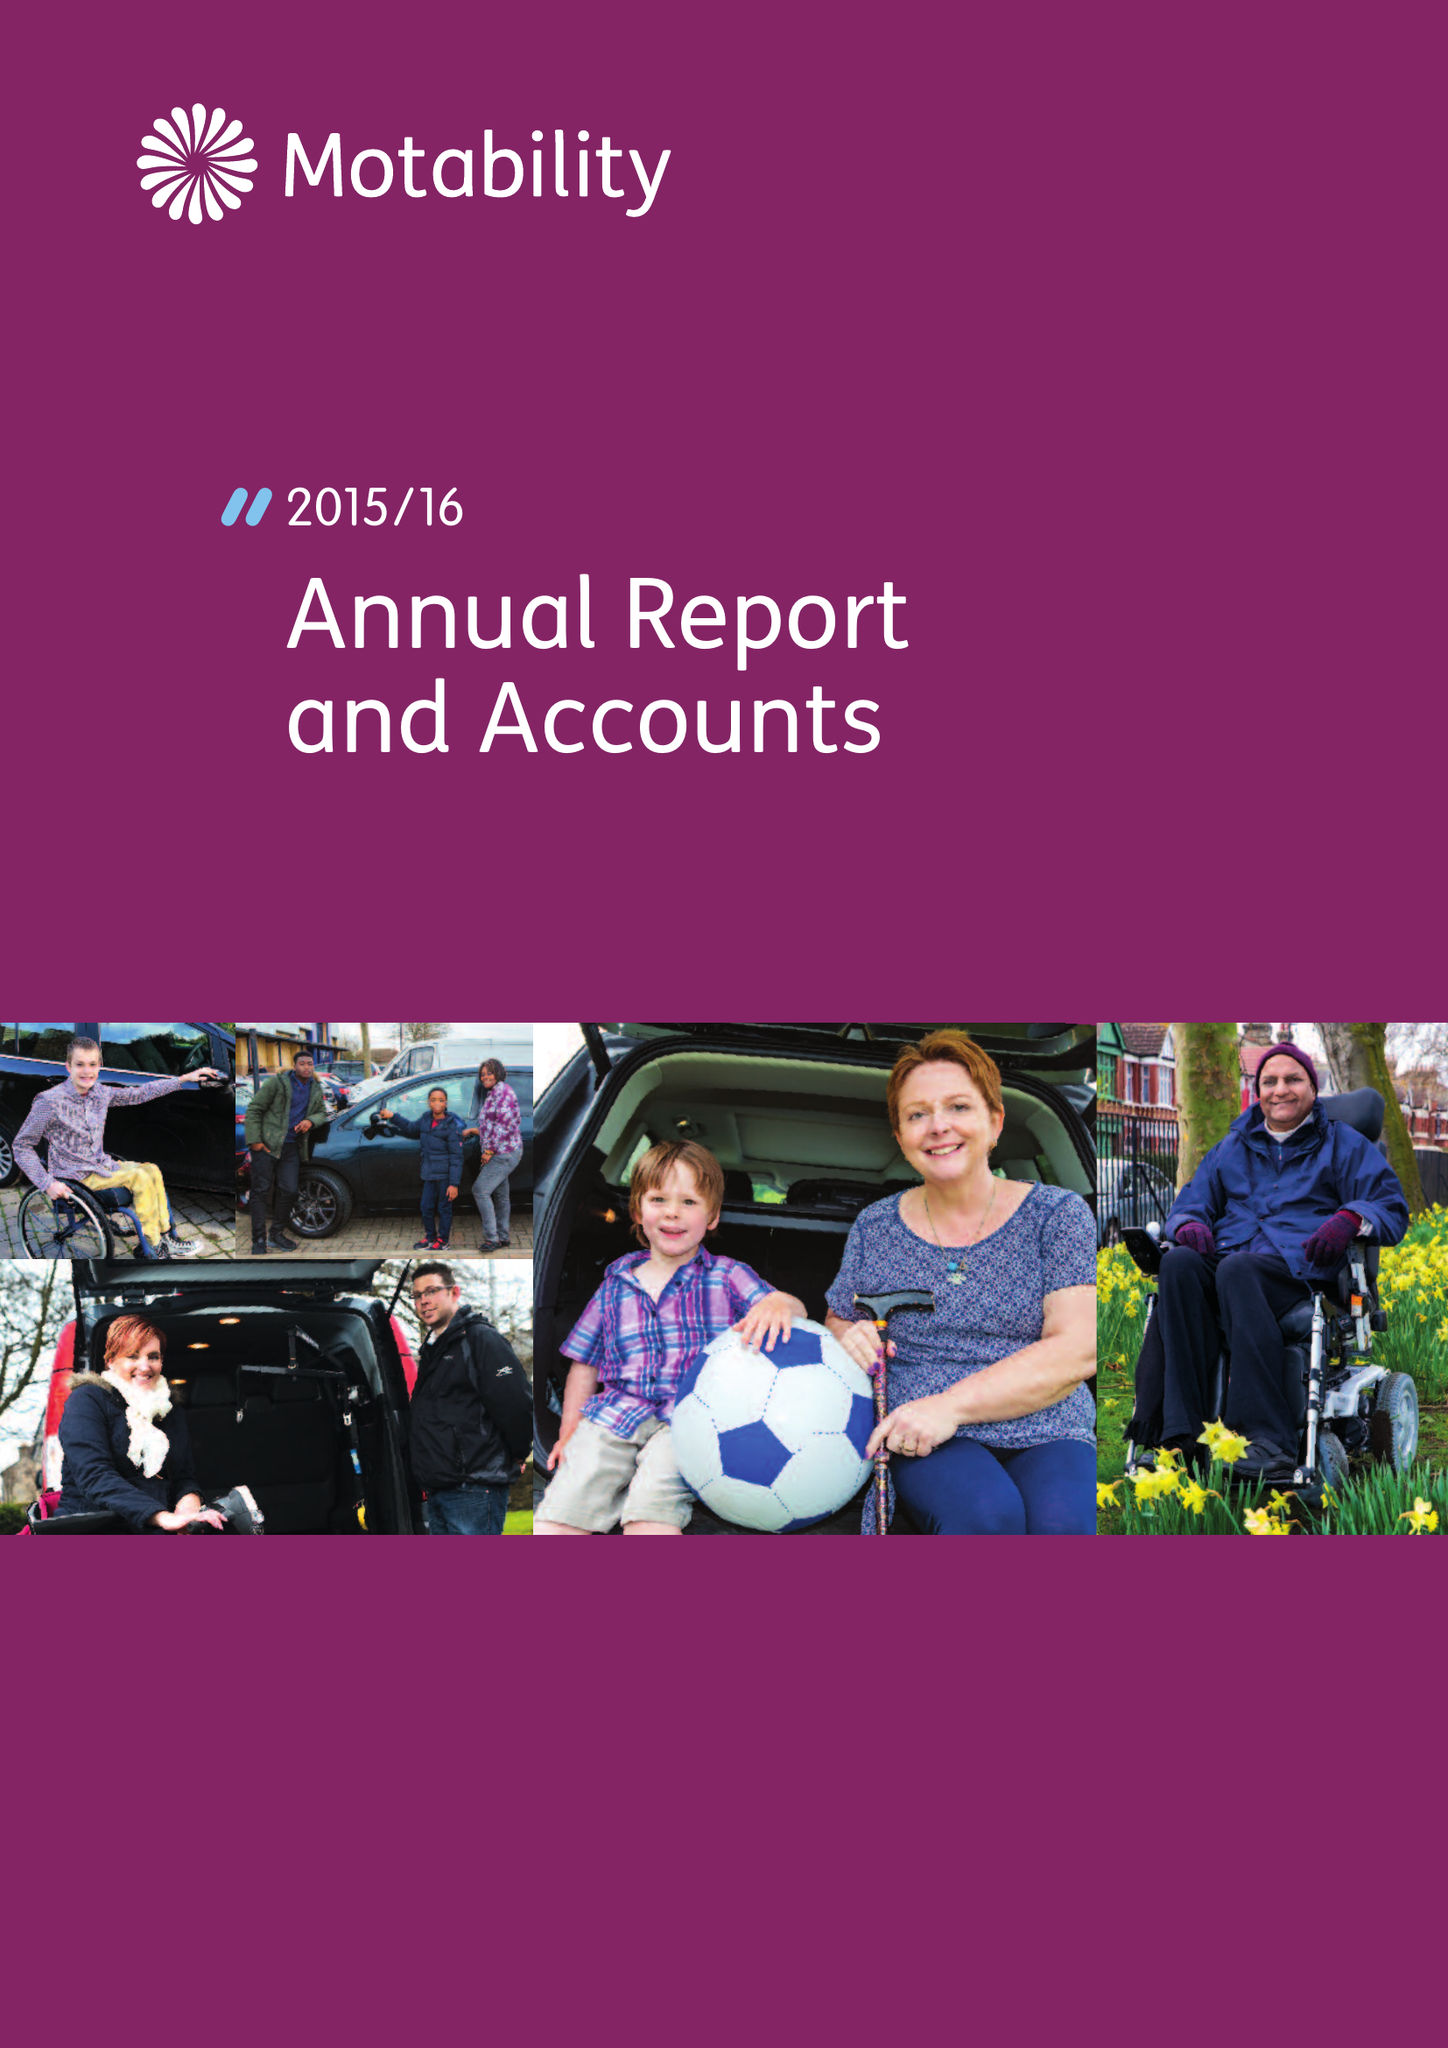What is the value for the report_date?
Answer the question using a single word or phrase. 2016-03-31 